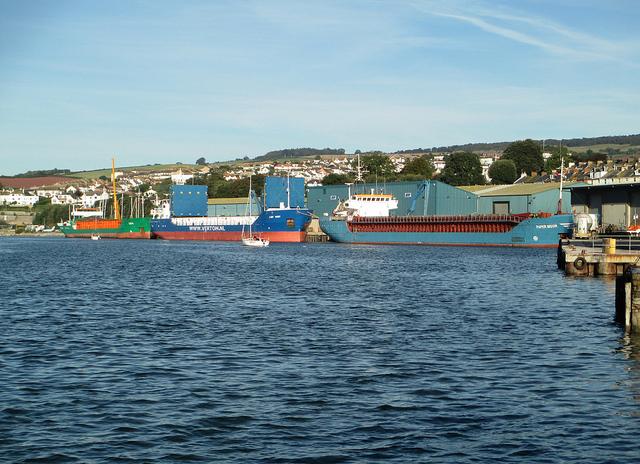Are these container ships?
Be succinct. Yes. Overcast or sunny?
Write a very short answer. Sunny. Does it look like rain?
Write a very short answer. No. Is there ocean water?
Short answer required. Yes. Which way is the wind blowing?
Keep it brief. East. Is the lake frozen?
Write a very short answer. No. Is that a passengers boat?
Keep it brief. No. Is the water placid?
Give a very brief answer. Yes. 